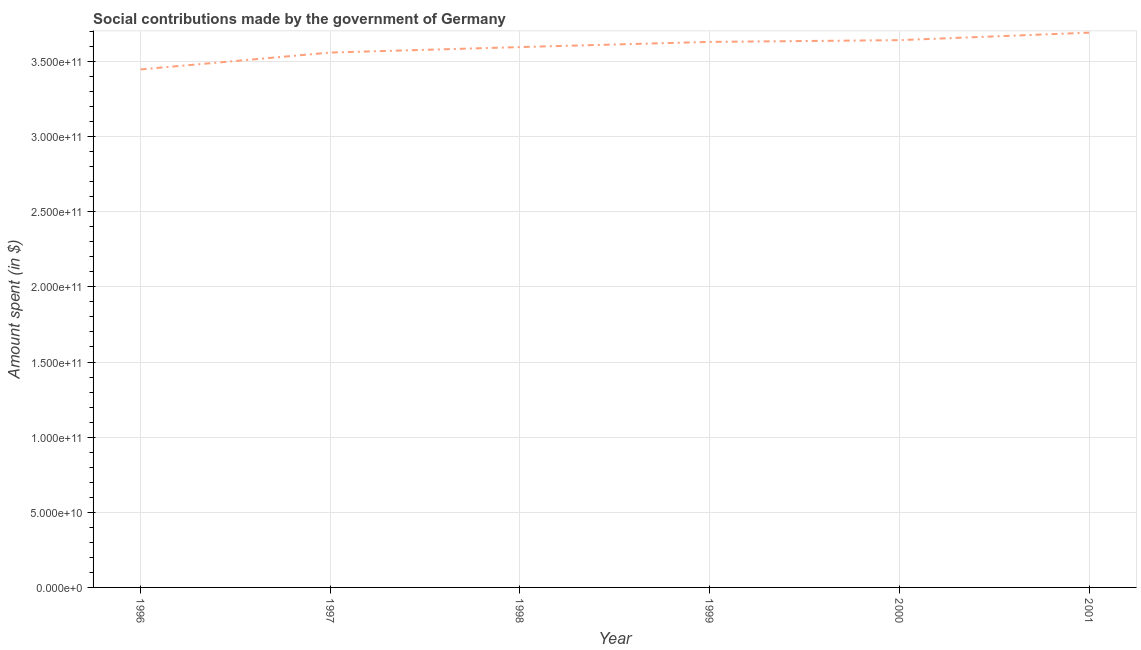What is the amount spent in making social contributions in 1999?
Make the answer very short. 3.63e+11. Across all years, what is the maximum amount spent in making social contributions?
Offer a very short reply. 3.69e+11. Across all years, what is the minimum amount spent in making social contributions?
Provide a short and direct response. 3.45e+11. In which year was the amount spent in making social contributions maximum?
Your response must be concise. 2001. What is the sum of the amount spent in making social contributions?
Ensure brevity in your answer.  2.16e+12. What is the difference between the amount spent in making social contributions in 1997 and 2001?
Make the answer very short. -1.32e+1. What is the average amount spent in making social contributions per year?
Ensure brevity in your answer.  3.59e+11. What is the median amount spent in making social contributions?
Ensure brevity in your answer.  3.61e+11. In how many years, is the amount spent in making social contributions greater than 80000000000 $?
Offer a very short reply. 6. What is the ratio of the amount spent in making social contributions in 1998 to that in 1999?
Offer a terse response. 0.99. Is the amount spent in making social contributions in 1999 less than that in 2001?
Offer a terse response. Yes. Is the difference between the amount spent in making social contributions in 1996 and 2001 greater than the difference between any two years?
Ensure brevity in your answer.  Yes. What is the difference between the highest and the second highest amount spent in making social contributions?
Your response must be concise. 4.98e+09. Is the sum of the amount spent in making social contributions in 1999 and 2000 greater than the maximum amount spent in making social contributions across all years?
Your response must be concise. Yes. What is the difference between the highest and the lowest amount spent in making social contributions?
Your response must be concise. 2.45e+1. Does the amount spent in making social contributions monotonically increase over the years?
Offer a terse response. Yes. How many lines are there?
Provide a short and direct response. 1. How many years are there in the graph?
Your answer should be compact. 6. What is the difference between two consecutive major ticks on the Y-axis?
Give a very brief answer. 5.00e+1. Are the values on the major ticks of Y-axis written in scientific E-notation?
Your answer should be very brief. Yes. Does the graph contain any zero values?
Your response must be concise. No. Does the graph contain grids?
Your answer should be very brief. Yes. What is the title of the graph?
Keep it short and to the point. Social contributions made by the government of Germany. What is the label or title of the X-axis?
Keep it short and to the point. Year. What is the label or title of the Y-axis?
Your answer should be compact. Amount spent (in $). What is the Amount spent (in $) in 1996?
Give a very brief answer. 3.45e+11. What is the Amount spent (in $) in 1997?
Provide a short and direct response. 3.56e+11. What is the Amount spent (in $) in 1998?
Ensure brevity in your answer.  3.60e+11. What is the Amount spent (in $) of 1999?
Provide a succinct answer. 3.63e+11. What is the Amount spent (in $) in 2000?
Your response must be concise. 3.64e+11. What is the Amount spent (in $) in 2001?
Keep it short and to the point. 3.69e+11. What is the difference between the Amount spent (in $) in 1996 and 1997?
Your answer should be compact. -1.12e+1. What is the difference between the Amount spent (in $) in 1996 and 1998?
Give a very brief answer. -1.49e+1. What is the difference between the Amount spent (in $) in 1996 and 1999?
Offer a terse response. -1.83e+1. What is the difference between the Amount spent (in $) in 1996 and 2000?
Offer a terse response. -1.95e+1. What is the difference between the Amount spent (in $) in 1996 and 2001?
Provide a succinct answer. -2.45e+1. What is the difference between the Amount spent (in $) in 1997 and 1998?
Make the answer very short. -3.65e+09. What is the difference between the Amount spent (in $) in 1997 and 1999?
Offer a very short reply. -7.09e+09. What is the difference between the Amount spent (in $) in 1997 and 2000?
Offer a very short reply. -8.26e+09. What is the difference between the Amount spent (in $) in 1997 and 2001?
Your response must be concise. -1.32e+1. What is the difference between the Amount spent (in $) in 1998 and 1999?
Your answer should be very brief. -3.44e+09. What is the difference between the Amount spent (in $) in 1998 and 2000?
Your answer should be very brief. -4.61e+09. What is the difference between the Amount spent (in $) in 1998 and 2001?
Your answer should be compact. -9.59e+09. What is the difference between the Amount spent (in $) in 1999 and 2000?
Your answer should be very brief. -1.17e+09. What is the difference between the Amount spent (in $) in 1999 and 2001?
Provide a succinct answer. -6.15e+09. What is the difference between the Amount spent (in $) in 2000 and 2001?
Offer a very short reply. -4.98e+09. What is the ratio of the Amount spent (in $) in 1996 to that in 1997?
Your answer should be very brief. 0.97. What is the ratio of the Amount spent (in $) in 1996 to that in 1998?
Keep it short and to the point. 0.96. What is the ratio of the Amount spent (in $) in 1996 to that in 2000?
Your response must be concise. 0.95. What is the ratio of the Amount spent (in $) in 1996 to that in 2001?
Ensure brevity in your answer.  0.93. What is the ratio of the Amount spent (in $) in 1997 to that in 2001?
Ensure brevity in your answer.  0.96. What is the ratio of the Amount spent (in $) in 1999 to that in 2000?
Your response must be concise. 1. What is the ratio of the Amount spent (in $) in 1999 to that in 2001?
Keep it short and to the point. 0.98. 